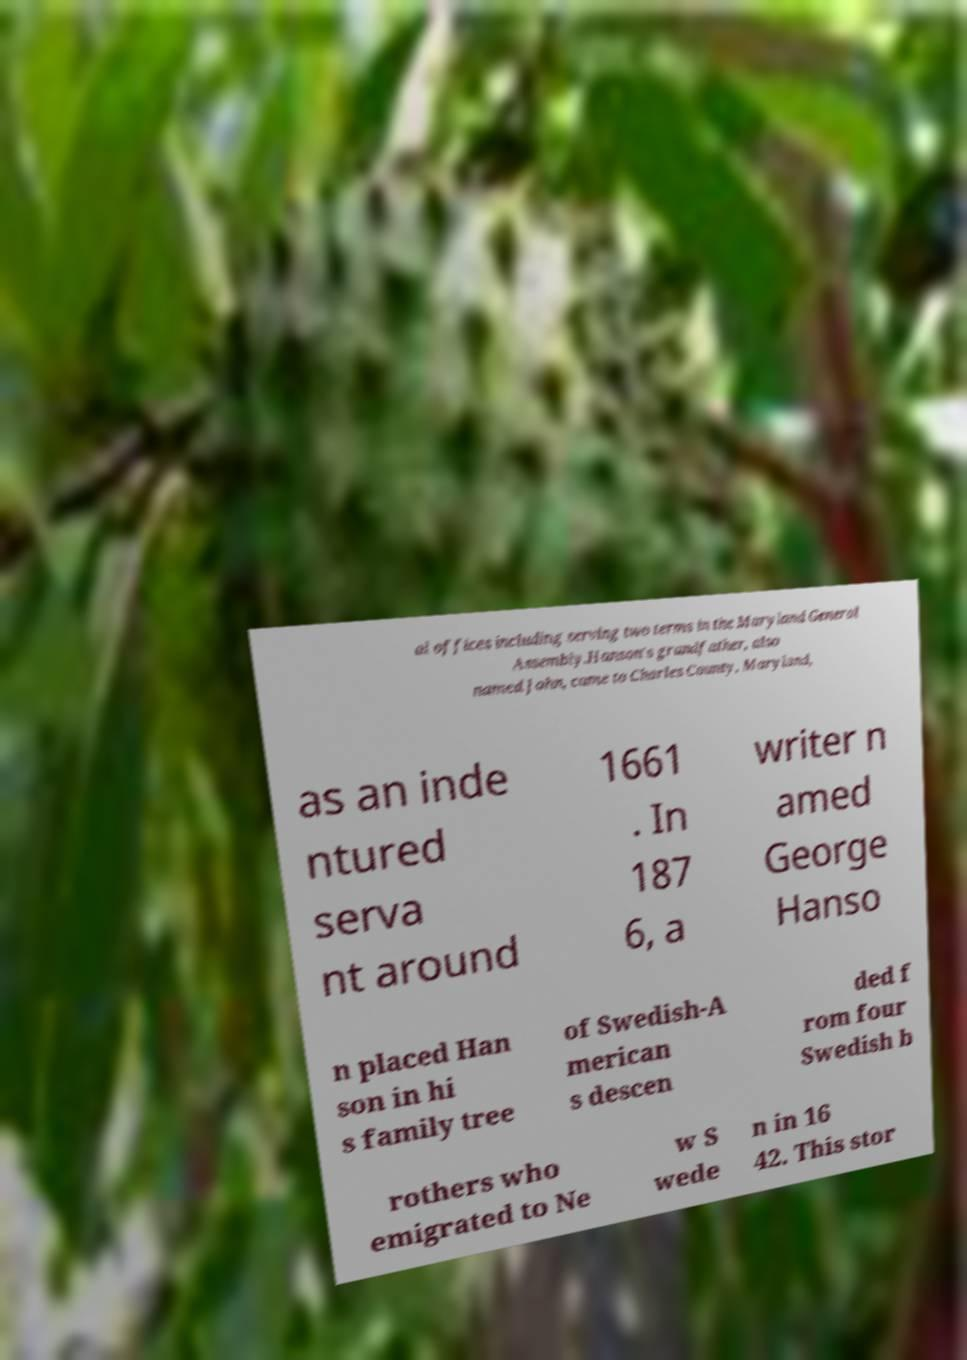What messages or text are displayed in this image? I need them in a readable, typed format. al offices including serving two terms in the Maryland General Assembly.Hanson's grandfather, also named John, came to Charles County, Maryland, as an inde ntured serva nt around 1661 . In 187 6, a writer n amed George Hanso n placed Han son in hi s family tree of Swedish-A merican s descen ded f rom four Swedish b rothers who emigrated to Ne w S wede n in 16 42. This stor 